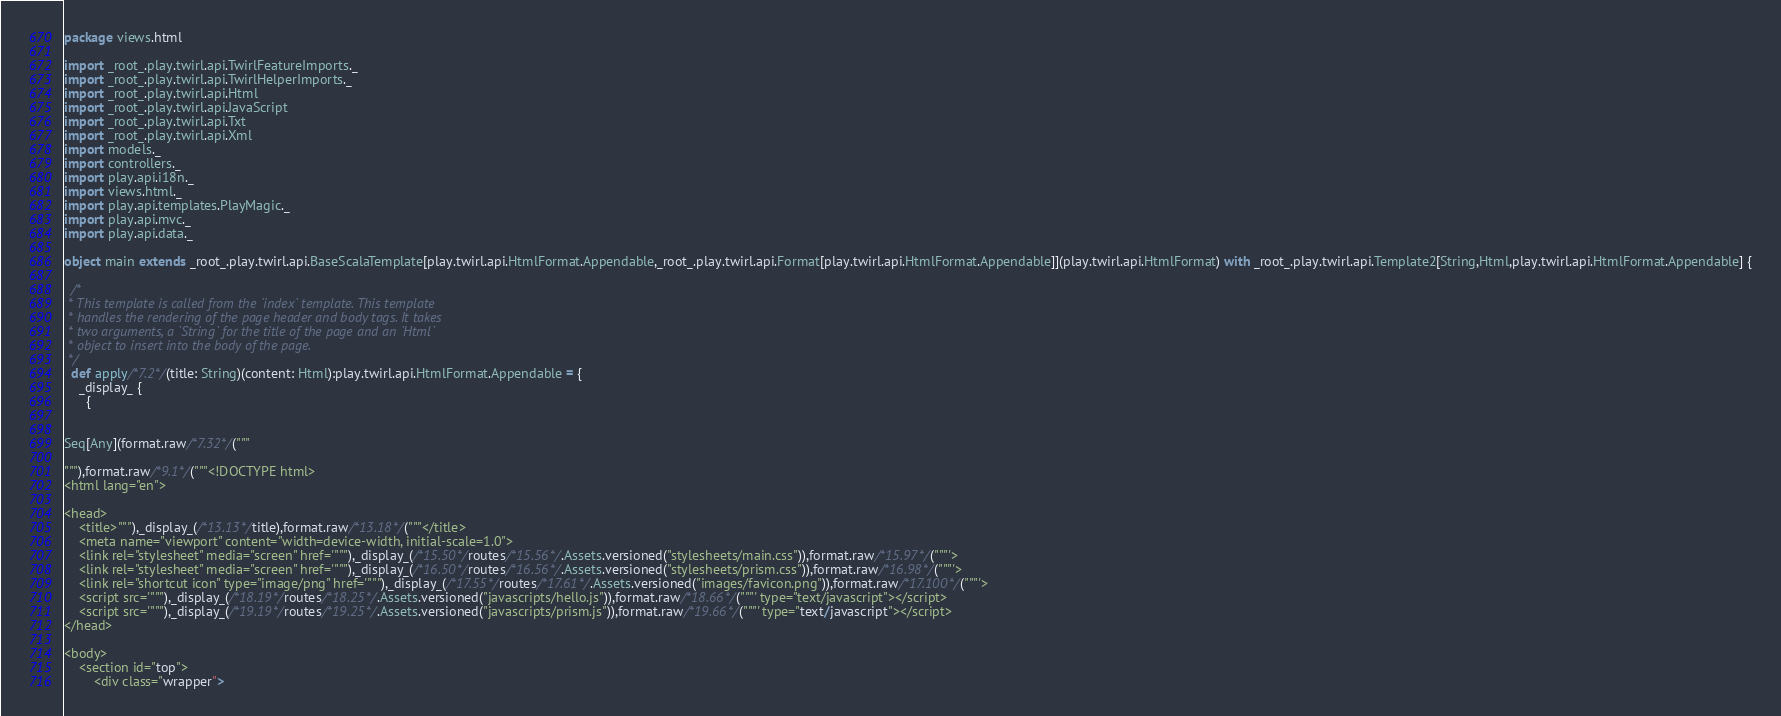<code> <loc_0><loc_0><loc_500><loc_500><_Scala_>
package views.html

import _root_.play.twirl.api.TwirlFeatureImports._
import _root_.play.twirl.api.TwirlHelperImports._
import _root_.play.twirl.api.Html
import _root_.play.twirl.api.JavaScript
import _root_.play.twirl.api.Txt
import _root_.play.twirl.api.Xml
import models._
import controllers._
import play.api.i18n._
import views.html._
import play.api.templates.PlayMagic._
import play.api.mvc._
import play.api.data._

object main extends _root_.play.twirl.api.BaseScalaTemplate[play.twirl.api.HtmlFormat.Appendable,_root_.play.twirl.api.Format[play.twirl.api.HtmlFormat.Appendable]](play.twirl.api.HtmlFormat) with _root_.play.twirl.api.Template2[String,Html,play.twirl.api.HtmlFormat.Appendable] {

  /*
 * This template is called from the `index` template. This template
 * handles the rendering of the page header and body tags. It takes
 * two arguments, a `String` for the title of the page and an `Html`
 * object to insert into the body of the page.
 */
  def apply/*7.2*/(title: String)(content: Html):play.twirl.api.HtmlFormat.Appendable = {
    _display_ {
      {


Seq[Any](format.raw/*7.32*/("""

"""),format.raw/*9.1*/("""<!DOCTYPE html>
<html lang="en">

<head>
    <title>"""),_display_(/*13.13*/title),format.raw/*13.18*/("""</title>
    <meta name="viewport" content="width=device-width, initial-scale=1.0">
    <link rel="stylesheet" media="screen" href='"""),_display_(/*15.50*/routes/*15.56*/.Assets.versioned("stylesheets/main.css")),format.raw/*15.97*/("""'>
    <link rel="stylesheet" media="screen" href='"""),_display_(/*16.50*/routes/*16.56*/.Assets.versioned("stylesheets/prism.css")),format.raw/*16.98*/("""'>
    <link rel="shortcut icon" type="image/png" href='"""),_display_(/*17.55*/routes/*17.61*/.Assets.versioned("images/favicon.png")),format.raw/*17.100*/("""'>
    <script src='"""),_display_(/*18.19*/routes/*18.25*/.Assets.versioned("javascripts/hello.js")),format.raw/*18.66*/("""' type="text/javascript"></script>
    <script src='"""),_display_(/*19.19*/routes/*19.25*/.Assets.versioned("javascripts/prism.js")),format.raw/*19.66*/("""' type="text/javascript"></script>
</head>

<body>
    <section id="top">
        <div class="wrapper"></code> 